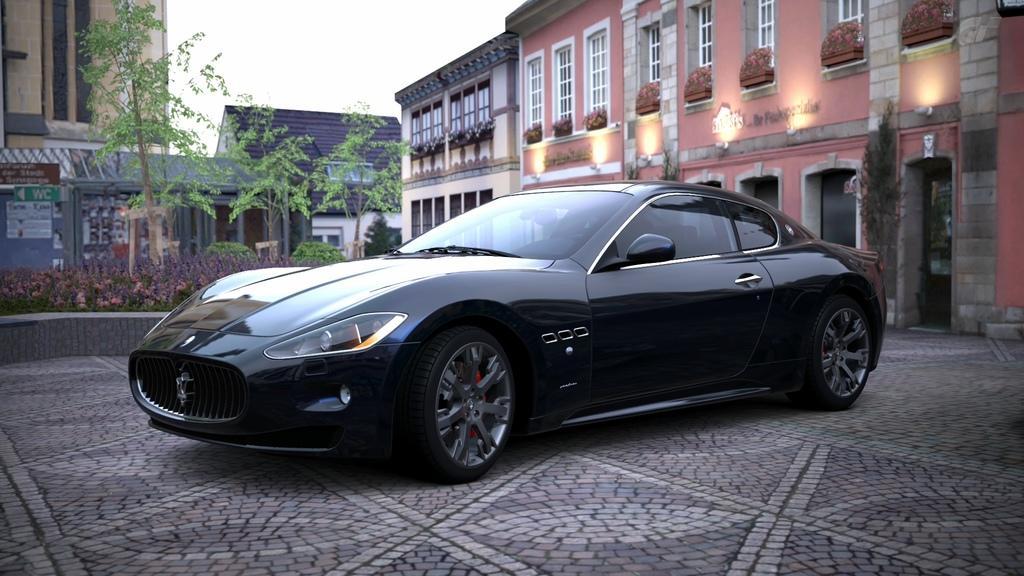Describe this image in one or two sentences. There is a black color vehicle on the floor. In the background, there are trees and plants on the ground, there are buildings which are having windows and there is sky. 